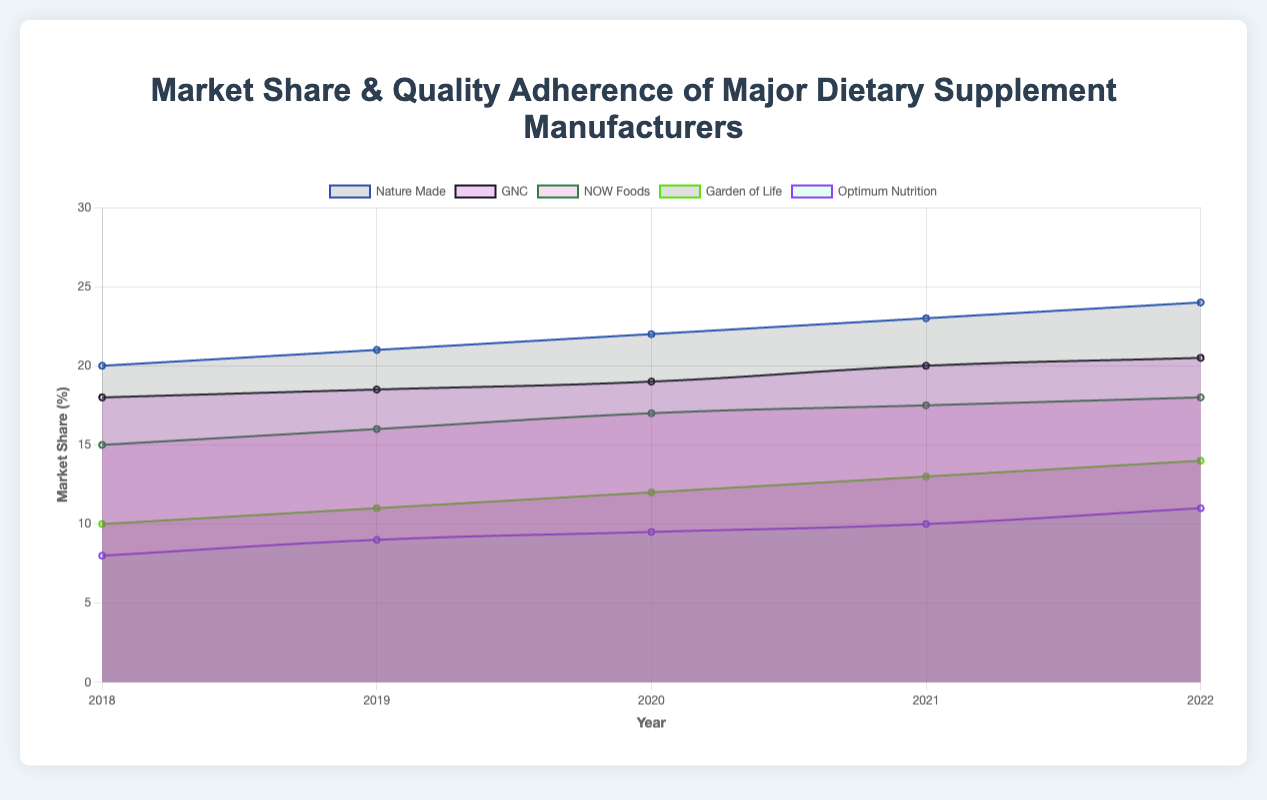What is the title of the figure? The title is usually placed at the top of the chart and provides a summary of what the chart represents. In this case, it reads, “Market Share & Quality Adherence of Major Dietary Supplement Manufacturers.”
Answer: Market Share & Quality Adherence of Major Dietary Supplement Manufacturers What does the X-axis represent? The X-axis represents the years from 2018 to 2022. This can be seen from the labeled data points on the horizontal axis.
Answer: Years from 2018 to 2022 Which manufacturer had the highest market share in 2022? From the figure, you can identify the data for 2022. Nature Made shows the highest market share with a value of 24%.
Answer: Nature Made How did the market share of NOW Foods change from 2018 to 2022? The market share of NOW Foods increased from 15% in 2018 to 18% in 2022. You can see the yearly increments at each data point along the graph.
Answer: Increased from 15% to 18% Compare the adherence to quality standards of GNC and Optimum Nutrition in 2021. Which was higher? To compare, locate the data points for adherence to quality standards for both GNC and Optimum Nutrition in 2021. GNC had an adherence rate of 0.89, while Optimum Nutrition had 0.90. Thus, Optimum Nutrition had a higher adherence rate.
Answer: Optimum Nutrition Which manufacturer shows a continuous increase in adherence to quality standards every year from 2018 to 2022? By examining the trend lines for adherence to quality standards, Nature Made shows a continuous increase each year from 2018 (0.9) to 2022 (0.96).
Answer: Nature Made What is the average market share of Garden of Life from 2018 to 2022? The average is calculated by summing the market share values from 2018 to 2022 and then dividing by 5. The values are 10, 11, 12, 13, and 14. So, (10 + 11 + 12 + 13 + 14) / 5 = 60 / 5 = 12.
Answer: 12 Which manufacturer had the lowest market share in 2019, and what was its value? In 2019, the manufacturer with the lowest market share is Optimum Nutrition, with a value of 9%. This can be seen by comparing all the values for 2019.
Answer: Optimum Nutrition, 9% By how much did the market share of GNC increase from 2020 to 2022? To find the increase, subtract the 2020 market share value from the 2022 value for GNC. That is, 20.5% in 2022 minus 19% in 2020 equals 1.5%.
Answer: 1.5% Rank the manufacturers by their adherence to quality standards in 2020 from highest to lowest. By examining the data points for adherence to quality standards in 2020, the ranking from highest to lowest is: Nature Made (0.93), Garden of Life (0.90), NOW Foods (0.89), GNC (0.88), and Optimum Nutrition (0.89).
Answer: Nature Made, Garden of Life, NOW Foods, GNC, Optimum Nutrition 